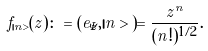Convert formula to latex. <formula><loc_0><loc_0><loc_500><loc_500>f _ { | n > } ( z ) \colon = ( e _ { \bar { z } } , | n > ) = \frac { z ^ { n } } { ( n ! ) ^ { 1 / 2 } } .</formula> 